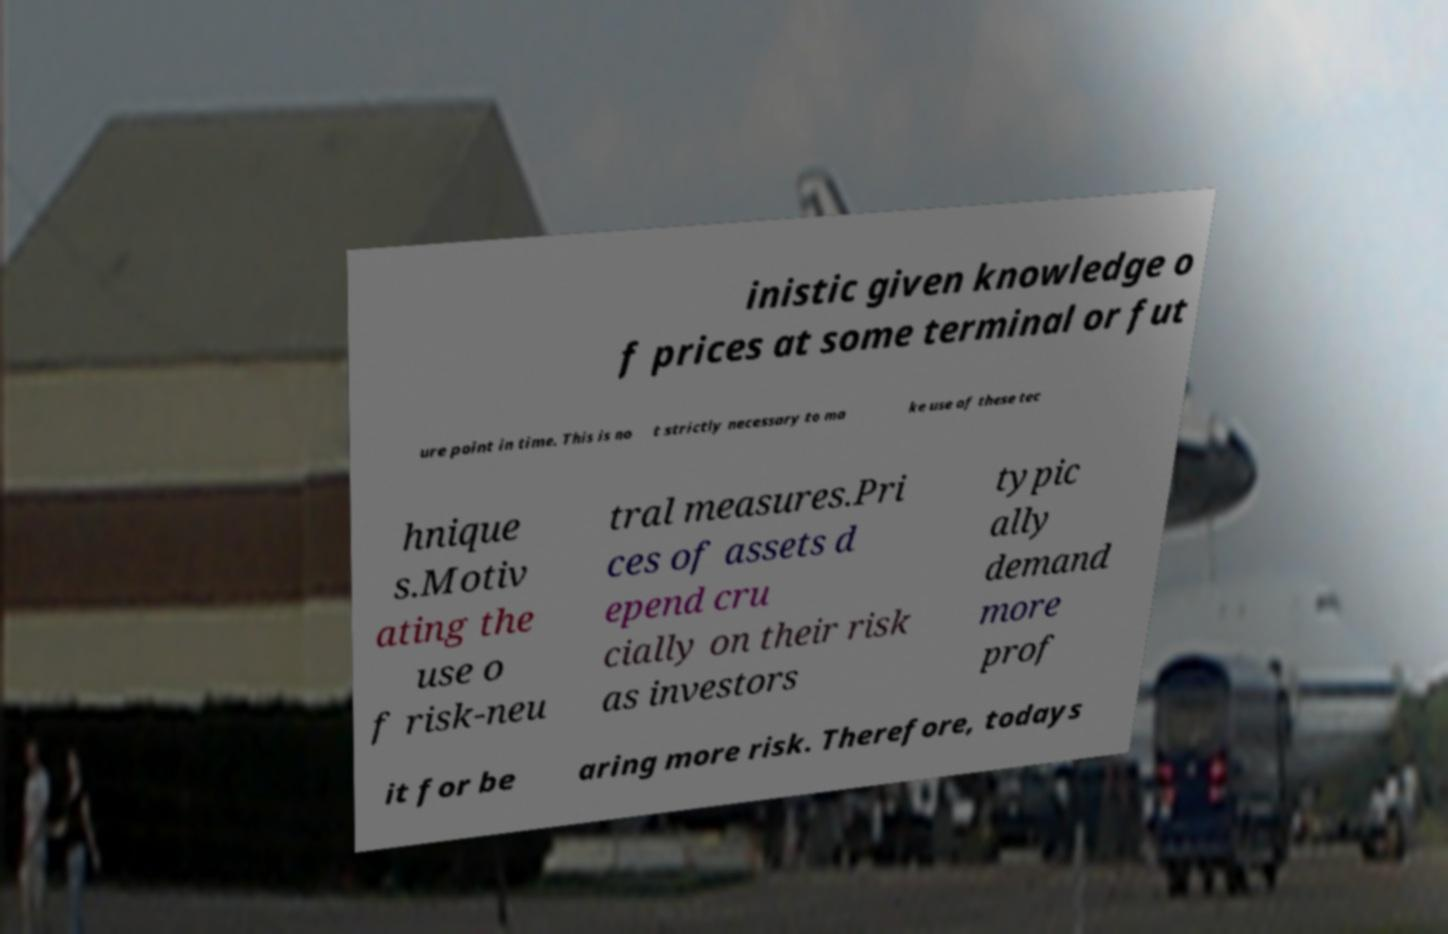Please identify and transcribe the text found in this image. inistic given knowledge o f prices at some terminal or fut ure point in time. This is no t strictly necessary to ma ke use of these tec hnique s.Motiv ating the use o f risk-neu tral measures.Pri ces of assets d epend cru cially on their risk as investors typic ally demand more prof it for be aring more risk. Therefore, todays 